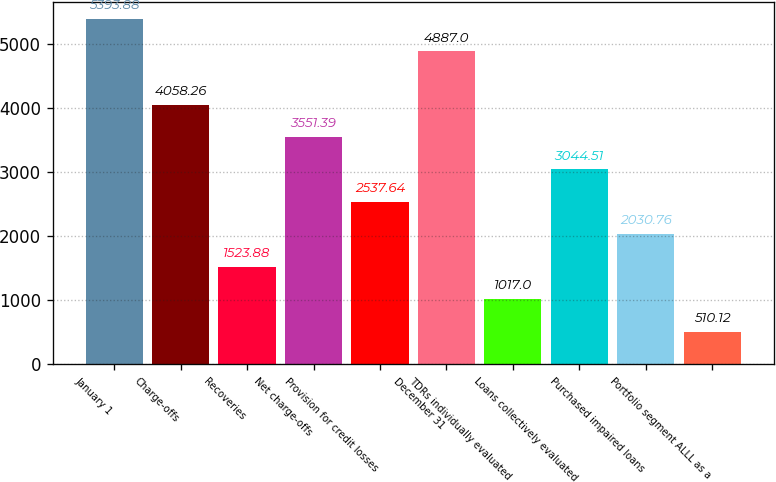Convert chart. <chart><loc_0><loc_0><loc_500><loc_500><bar_chart><fcel>January 1<fcel>Charge-offs<fcel>Recoveries<fcel>Net charge-offs<fcel>Provision for credit losses<fcel>December 31<fcel>TDRs individually evaluated<fcel>Loans collectively evaluated<fcel>Purchased impaired loans<fcel>Portfolio segment ALLL as a<nl><fcel>5393.88<fcel>4058.26<fcel>1523.88<fcel>3551.39<fcel>2537.64<fcel>4887<fcel>1017<fcel>3044.51<fcel>2030.76<fcel>510.12<nl></chart> 